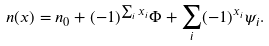<formula> <loc_0><loc_0><loc_500><loc_500>n ( { x } ) = n _ { 0 } + ( - 1 ) ^ { \sum _ { i } x _ { i } } \Phi + \sum _ { i } ( - 1 ) ^ { x _ { i } } \psi _ { i } .</formula> 